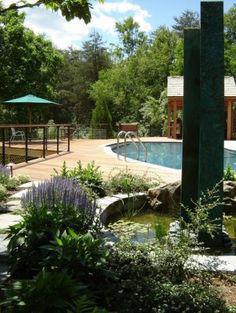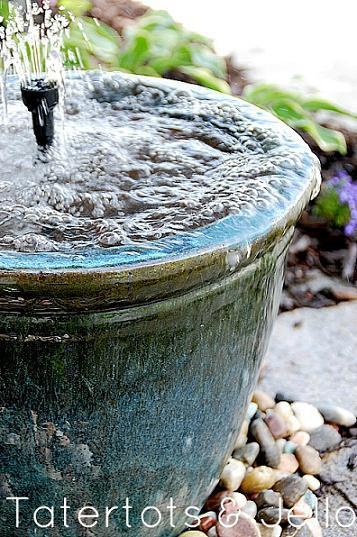The first image is the image on the left, the second image is the image on the right. Analyze the images presented: Is the assertion "Each image features exactly one upright pottery vessel." valid? Answer yes or no. No. The first image is the image on the left, the second image is the image on the right. Considering the images on both sides, is "Two large urn shaped pots are placed in outdoor garden settings, with at least one being used as a water fountain." valid? Answer yes or no. No. 